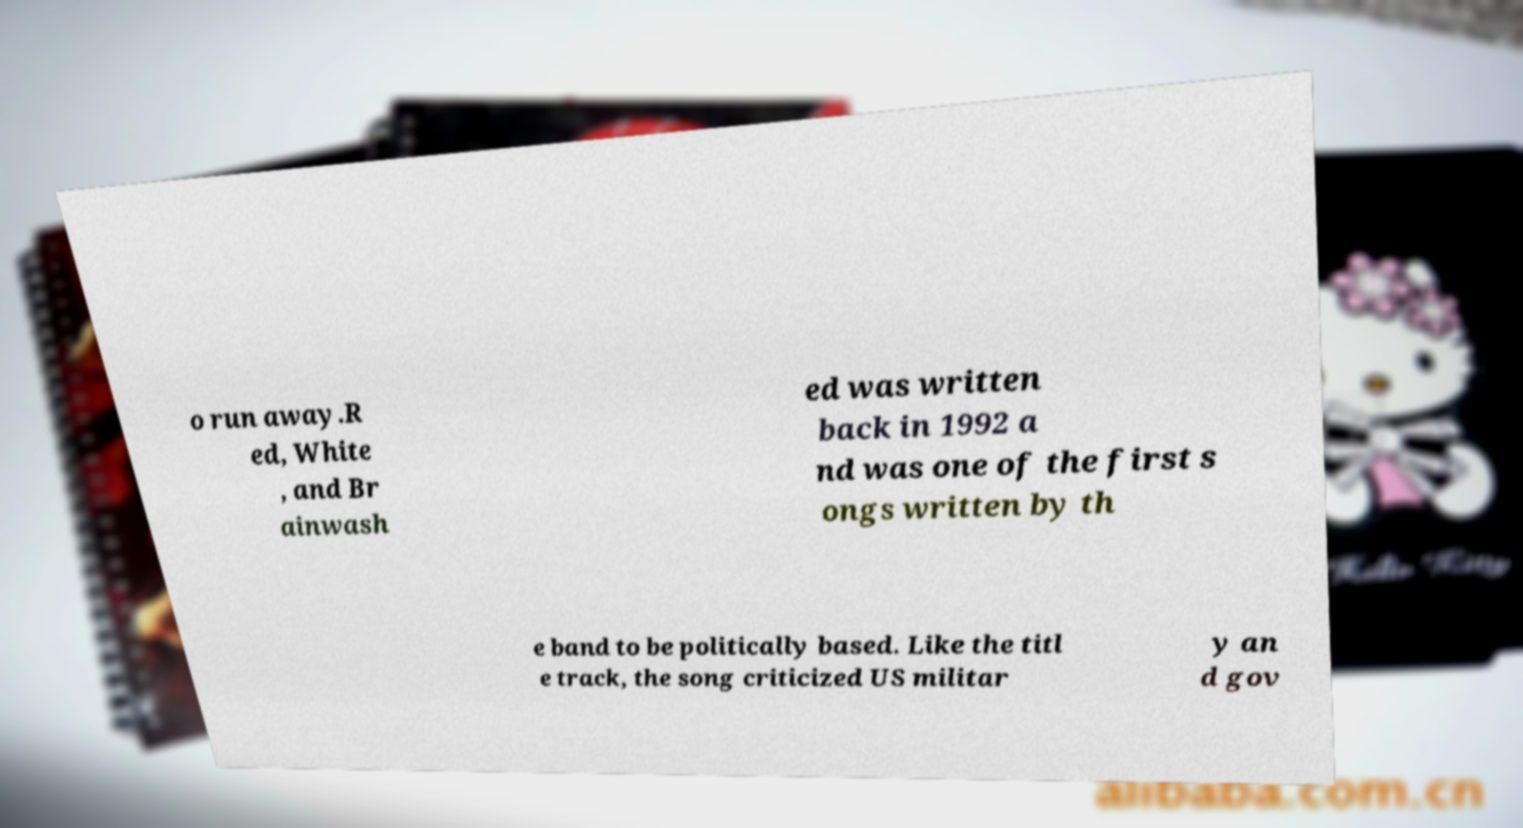Please identify and transcribe the text found in this image. o run away.R ed, White , and Br ainwash ed was written back in 1992 a nd was one of the first s ongs written by th e band to be politically based. Like the titl e track, the song criticized US militar y an d gov 